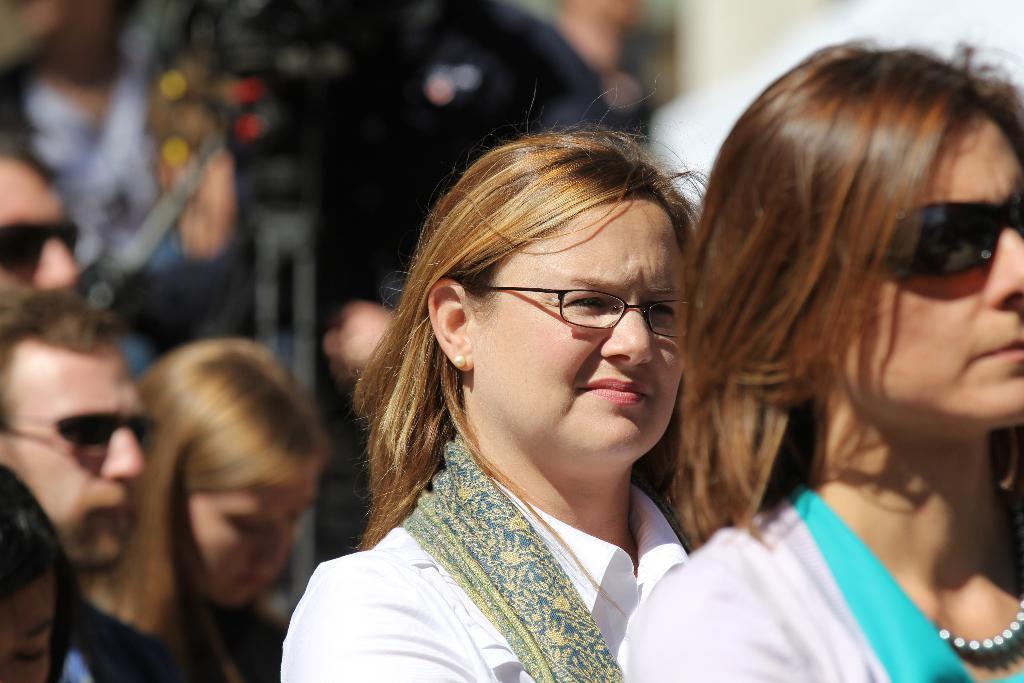In one or two sentences, can you explain what this image depicts? In this picture I can see few people standing and looks like a camera to the stand in the back. 